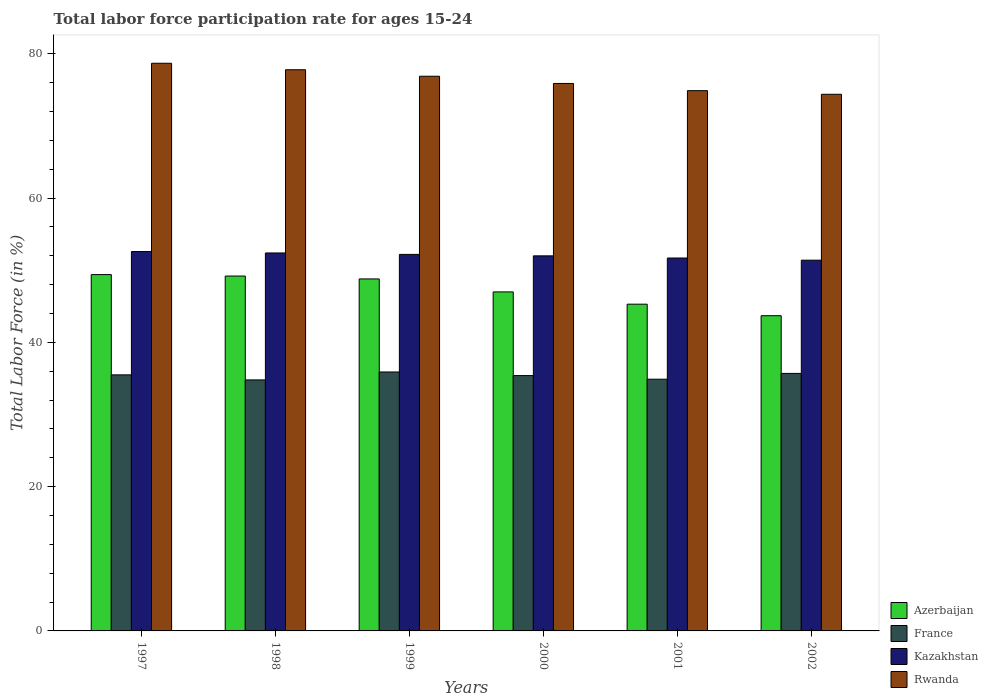How many different coloured bars are there?
Your answer should be very brief. 4. How many groups of bars are there?
Offer a terse response. 6. Are the number of bars per tick equal to the number of legend labels?
Give a very brief answer. Yes. Are the number of bars on each tick of the X-axis equal?
Offer a very short reply. Yes. How many bars are there on the 4th tick from the left?
Give a very brief answer. 4. What is the label of the 6th group of bars from the left?
Your answer should be compact. 2002. What is the labor force participation rate in France in 1998?
Give a very brief answer. 34.8. Across all years, what is the maximum labor force participation rate in Azerbaijan?
Offer a very short reply. 49.4. Across all years, what is the minimum labor force participation rate in Kazakhstan?
Offer a very short reply. 51.4. What is the total labor force participation rate in France in the graph?
Ensure brevity in your answer.  212.2. What is the difference between the labor force participation rate in Azerbaijan in 1999 and that in 2002?
Ensure brevity in your answer.  5.1. What is the difference between the labor force participation rate in France in 2000 and the labor force participation rate in Azerbaijan in 2002?
Your response must be concise. -8.3. What is the average labor force participation rate in Azerbaijan per year?
Provide a succinct answer. 47.23. In the year 2000, what is the difference between the labor force participation rate in Rwanda and labor force participation rate in Kazakhstan?
Your answer should be compact. 23.9. What is the ratio of the labor force participation rate in France in 1998 to that in 2000?
Provide a short and direct response. 0.98. Is the labor force participation rate in Azerbaijan in 2000 less than that in 2002?
Your answer should be very brief. No. Is the difference between the labor force participation rate in Rwanda in 1997 and 2001 greater than the difference between the labor force participation rate in Kazakhstan in 1997 and 2001?
Your response must be concise. Yes. What is the difference between the highest and the second highest labor force participation rate in Rwanda?
Keep it short and to the point. 0.9. What is the difference between the highest and the lowest labor force participation rate in Rwanda?
Your answer should be very brief. 4.3. In how many years, is the labor force participation rate in France greater than the average labor force participation rate in France taken over all years?
Provide a short and direct response. 4. Is the sum of the labor force participation rate in Rwanda in 1997 and 2000 greater than the maximum labor force participation rate in Azerbaijan across all years?
Offer a terse response. Yes. Is it the case that in every year, the sum of the labor force participation rate in Kazakhstan and labor force participation rate in France is greater than the sum of labor force participation rate in Azerbaijan and labor force participation rate in Rwanda?
Keep it short and to the point. No. What does the 3rd bar from the left in 1999 represents?
Give a very brief answer. Kazakhstan. What does the 1st bar from the right in 2000 represents?
Ensure brevity in your answer.  Rwanda. Is it the case that in every year, the sum of the labor force participation rate in France and labor force participation rate in Rwanda is greater than the labor force participation rate in Azerbaijan?
Make the answer very short. Yes. How many bars are there?
Keep it short and to the point. 24. Are all the bars in the graph horizontal?
Your answer should be compact. No. How many years are there in the graph?
Your answer should be compact. 6. Are the values on the major ticks of Y-axis written in scientific E-notation?
Your answer should be very brief. No. Does the graph contain grids?
Your answer should be very brief. No. Where does the legend appear in the graph?
Offer a terse response. Bottom right. How are the legend labels stacked?
Keep it short and to the point. Vertical. What is the title of the graph?
Give a very brief answer. Total labor force participation rate for ages 15-24. Does "Serbia" appear as one of the legend labels in the graph?
Ensure brevity in your answer.  No. What is the label or title of the X-axis?
Your answer should be very brief. Years. What is the Total Labor Force (in %) in Azerbaijan in 1997?
Give a very brief answer. 49.4. What is the Total Labor Force (in %) in France in 1997?
Your answer should be very brief. 35.5. What is the Total Labor Force (in %) in Kazakhstan in 1997?
Provide a short and direct response. 52.6. What is the Total Labor Force (in %) in Rwanda in 1997?
Make the answer very short. 78.7. What is the Total Labor Force (in %) in Azerbaijan in 1998?
Your answer should be compact. 49.2. What is the Total Labor Force (in %) of France in 1998?
Offer a terse response. 34.8. What is the Total Labor Force (in %) of Kazakhstan in 1998?
Give a very brief answer. 52.4. What is the Total Labor Force (in %) of Rwanda in 1998?
Offer a terse response. 77.8. What is the Total Labor Force (in %) in Azerbaijan in 1999?
Offer a terse response. 48.8. What is the Total Labor Force (in %) in France in 1999?
Ensure brevity in your answer.  35.9. What is the Total Labor Force (in %) of Kazakhstan in 1999?
Provide a succinct answer. 52.2. What is the Total Labor Force (in %) of Rwanda in 1999?
Ensure brevity in your answer.  76.9. What is the Total Labor Force (in %) in France in 2000?
Provide a succinct answer. 35.4. What is the Total Labor Force (in %) of Kazakhstan in 2000?
Offer a terse response. 52. What is the Total Labor Force (in %) of Rwanda in 2000?
Provide a short and direct response. 75.9. What is the Total Labor Force (in %) of Azerbaijan in 2001?
Ensure brevity in your answer.  45.3. What is the Total Labor Force (in %) in France in 2001?
Your response must be concise. 34.9. What is the Total Labor Force (in %) in Kazakhstan in 2001?
Give a very brief answer. 51.7. What is the Total Labor Force (in %) of Rwanda in 2001?
Ensure brevity in your answer.  74.9. What is the Total Labor Force (in %) of Azerbaijan in 2002?
Make the answer very short. 43.7. What is the Total Labor Force (in %) in France in 2002?
Make the answer very short. 35.7. What is the Total Labor Force (in %) of Kazakhstan in 2002?
Provide a succinct answer. 51.4. What is the Total Labor Force (in %) in Rwanda in 2002?
Your response must be concise. 74.4. Across all years, what is the maximum Total Labor Force (in %) in Azerbaijan?
Your answer should be compact. 49.4. Across all years, what is the maximum Total Labor Force (in %) of France?
Your answer should be compact. 35.9. Across all years, what is the maximum Total Labor Force (in %) in Kazakhstan?
Provide a succinct answer. 52.6. Across all years, what is the maximum Total Labor Force (in %) of Rwanda?
Offer a terse response. 78.7. Across all years, what is the minimum Total Labor Force (in %) in Azerbaijan?
Your answer should be very brief. 43.7. Across all years, what is the minimum Total Labor Force (in %) of France?
Provide a short and direct response. 34.8. Across all years, what is the minimum Total Labor Force (in %) in Kazakhstan?
Provide a short and direct response. 51.4. Across all years, what is the minimum Total Labor Force (in %) of Rwanda?
Your answer should be very brief. 74.4. What is the total Total Labor Force (in %) of Azerbaijan in the graph?
Offer a terse response. 283.4. What is the total Total Labor Force (in %) in France in the graph?
Your answer should be compact. 212.2. What is the total Total Labor Force (in %) of Kazakhstan in the graph?
Make the answer very short. 312.3. What is the total Total Labor Force (in %) in Rwanda in the graph?
Offer a very short reply. 458.6. What is the difference between the Total Labor Force (in %) of Rwanda in 1997 and that in 1998?
Give a very brief answer. 0.9. What is the difference between the Total Labor Force (in %) of Azerbaijan in 1997 and that in 1999?
Ensure brevity in your answer.  0.6. What is the difference between the Total Labor Force (in %) of Rwanda in 1997 and that in 1999?
Your answer should be very brief. 1.8. What is the difference between the Total Labor Force (in %) in France in 1997 and that in 2000?
Offer a very short reply. 0.1. What is the difference between the Total Labor Force (in %) in Rwanda in 1997 and that in 2000?
Your answer should be compact. 2.8. What is the difference between the Total Labor Force (in %) of France in 1997 and that in 2001?
Give a very brief answer. 0.6. What is the difference between the Total Labor Force (in %) in Kazakhstan in 1997 and that in 2001?
Provide a succinct answer. 0.9. What is the difference between the Total Labor Force (in %) in Rwanda in 1997 and that in 2001?
Your answer should be compact. 3.8. What is the difference between the Total Labor Force (in %) of France in 1997 and that in 2002?
Provide a succinct answer. -0.2. What is the difference between the Total Labor Force (in %) of Rwanda in 1997 and that in 2002?
Keep it short and to the point. 4.3. What is the difference between the Total Labor Force (in %) of France in 1998 and that in 1999?
Give a very brief answer. -1.1. What is the difference between the Total Labor Force (in %) in Rwanda in 1998 and that in 1999?
Ensure brevity in your answer.  0.9. What is the difference between the Total Labor Force (in %) of Azerbaijan in 1998 and that in 2000?
Make the answer very short. 2.2. What is the difference between the Total Labor Force (in %) in France in 1998 and that in 2000?
Provide a short and direct response. -0.6. What is the difference between the Total Labor Force (in %) in Kazakhstan in 1998 and that in 2000?
Give a very brief answer. 0.4. What is the difference between the Total Labor Force (in %) in Azerbaijan in 1998 and that in 2001?
Keep it short and to the point. 3.9. What is the difference between the Total Labor Force (in %) of France in 1998 and that in 2001?
Provide a succinct answer. -0.1. What is the difference between the Total Labor Force (in %) in France in 1998 and that in 2002?
Keep it short and to the point. -0.9. What is the difference between the Total Labor Force (in %) in Kazakhstan in 1998 and that in 2002?
Keep it short and to the point. 1. What is the difference between the Total Labor Force (in %) of Rwanda in 1998 and that in 2002?
Your response must be concise. 3.4. What is the difference between the Total Labor Force (in %) in France in 1999 and that in 2000?
Offer a very short reply. 0.5. What is the difference between the Total Labor Force (in %) of Azerbaijan in 1999 and that in 2002?
Provide a short and direct response. 5.1. What is the difference between the Total Labor Force (in %) of Rwanda in 1999 and that in 2002?
Make the answer very short. 2.5. What is the difference between the Total Labor Force (in %) of Azerbaijan in 2000 and that in 2001?
Your answer should be very brief. 1.7. What is the difference between the Total Labor Force (in %) in France in 2000 and that in 2002?
Provide a succinct answer. -0.3. What is the difference between the Total Labor Force (in %) of Rwanda in 2000 and that in 2002?
Offer a terse response. 1.5. What is the difference between the Total Labor Force (in %) in Rwanda in 2001 and that in 2002?
Offer a very short reply. 0.5. What is the difference between the Total Labor Force (in %) in Azerbaijan in 1997 and the Total Labor Force (in %) in Kazakhstan in 1998?
Make the answer very short. -3. What is the difference between the Total Labor Force (in %) in Azerbaijan in 1997 and the Total Labor Force (in %) in Rwanda in 1998?
Ensure brevity in your answer.  -28.4. What is the difference between the Total Labor Force (in %) in France in 1997 and the Total Labor Force (in %) in Kazakhstan in 1998?
Keep it short and to the point. -16.9. What is the difference between the Total Labor Force (in %) of France in 1997 and the Total Labor Force (in %) of Rwanda in 1998?
Ensure brevity in your answer.  -42.3. What is the difference between the Total Labor Force (in %) in Kazakhstan in 1997 and the Total Labor Force (in %) in Rwanda in 1998?
Keep it short and to the point. -25.2. What is the difference between the Total Labor Force (in %) of Azerbaijan in 1997 and the Total Labor Force (in %) of Kazakhstan in 1999?
Give a very brief answer. -2.8. What is the difference between the Total Labor Force (in %) of Azerbaijan in 1997 and the Total Labor Force (in %) of Rwanda in 1999?
Your answer should be compact. -27.5. What is the difference between the Total Labor Force (in %) in France in 1997 and the Total Labor Force (in %) in Kazakhstan in 1999?
Offer a terse response. -16.7. What is the difference between the Total Labor Force (in %) in France in 1997 and the Total Labor Force (in %) in Rwanda in 1999?
Ensure brevity in your answer.  -41.4. What is the difference between the Total Labor Force (in %) of Kazakhstan in 1997 and the Total Labor Force (in %) of Rwanda in 1999?
Your answer should be compact. -24.3. What is the difference between the Total Labor Force (in %) in Azerbaijan in 1997 and the Total Labor Force (in %) in Rwanda in 2000?
Make the answer very short. -26.5. What is the difference between the Total Labor Force (in %) of France in 1997 and the Total Labor Force (in %) of Kazakhstan in 2000?
Give a very brief answer. -16.5. What is the difference between the Total Labor Force (in %) of France in 1997 and the Total Labor Force (in %) of Rwanda in 2000?
Give a very brief answer. -40.4. What is the difference between the Total Labor Force (in %) in Kazakhstan in 1997 and the Total Labor Force (in %) in Rwanda in 2000?
Your answer should be very brief. -23.3. What is the difference between the Total Labor Force (in %) in Azerbaijan in 1997 and the Total Labor Force (in %) in Rwanda in 2001?
Your answer should be compact. -25.5. What is the difference between the Total Labor Force (in %) in France in 1997 and the Total Labor Force (in %) in Kazakhstan in 2001?
Your response must be concise. -16.2. What is the difference between the Total Labor Force (in %) of France in 1997 and the Total Labor Force (in %) of Rwanda in 2001?
Your answer should be compact. -39.4. What is the difference between the Total Labor Force (in %) of Kazakhstan in 1997 and the Total Labor Force (in %) of Rwanda in 2001?
Your response must be concise. -22.3. What is the difference between the Total Labor Force (in %) in Azerbaijan in 1997 and the Total Labor Force (in %) in Rwanda in 2002?
Offer a terse response. -25. What is the difference between the Total Labor Force (in %) of France in 1997 and the Total Labor Force (in %) of Kazakhstan in 2002?
Your answer should be very brief. -15.9. What is the difference between the Total Labor Force (in %) of France in 1997 and the Total Labor Force (in %) of Rwanda in 2002?
Your answer should be very brief. -38.9. What is the difference between the Total Labor Force (in %) of Kazakhstan in 1997 and the Total Labor Force (in %) of Rwanda in 2002?
Ensure brevity in your answer.  -21.8. What is the difference between the Total Labor Force (in %) in Azerbaijan in 1998 and the Total Labor Force (in %) in Kazakhstan in 1999?
Offer a very short reply. -3. What is the difference between the Total Labor Force (in %) in Azerbaijan in 1998 and the Total Labor Force (in %) in Rwanda in 1999?
Provide a short and direct response. -27.7. What is the difference between the Total Labor Force (in %) in France in 1998 and the Total Labor Force (in %) in Kazakhstan in 1999?
Give a very brief answer. -17.4. What is the difference between the Total Labor Force (in %) of France in 1998 and the Total Labor Force (in %) of Rwanda in 1999?
Your answer should be compact. -42.1. What is the difference between the Total Labor Force (in %) of Kazakhstan in 1998 and the Total Labor Force (in %) of Rwanda in 1999?
Ensure brevity in your answer.  -24.5. What is the difference between the Total Labor Force (in %) in Azerbaijan in 1998 and the Total Labor Force (in %) in Kazakhstan in 2000?
Your answer should be compact. -2.8. What is the difference between the Total Labor Force (in %) of Azerbaijan in 1998 and the Total Labor Force (in %) of Rwanda in 2000?
Provide a succinct answer. -26.7. What is the difference between the Total Labor Force (in %) in France in 1998 and the Total Labor Force (in %) in Kazakhstan in 2000?
Your answer should be compact. -17.2. What is the difference between the Total Labor Force (in %) of France in 1998 and the Total Labor Force (in %) of Rwanda in 2000?
Keep it short and to the point. -41.1. What is the difference between the Total Labor Force (in %) of Kazakhstan in 1998 and the Total Labor Force (in %) of Rwanda in 2000?
Make the answer very short. -23.5. What is the difference between the Total Labor Force (in %) in Azerbaijan in 1998 and the Total Labor Force (in %) in France in 2001?
Provide a short and direct response. 14.3. What is the difference between the Total Labor Force (in %) in Azerbaijan in 1998 and the Total Labor Force (in %) in Kazakhstan in 2001?
Offer a terse response. -2.5. What is the difference between the Total Labor Force (in %) in Azerbaijan in 1998 and the Total Labor Force (in %) in Rwanda in 2001?
Offer a terse response. -25.7. What is the difference between the Total Labor Force (in %) of France in 1998 and the Total Labor Force (in %) of Kazakhstan in 2001?
Offer a terse response. -16.9. What is the difference between the Total Labor Force (in %) in France in 1998 and the Total Labor Force (in %) in Rwanda in 2001?
Provide a short and direct response. -40.1. What is the difference between the Total Labor Force (in %) in Kazakhstan in 1998 and the Total Labor Force (in %) in Rwanda in 2001?
Provide a succinct answer. -22.5. What is the difference between the Total Labor Force (in %) of Azerbaijan in 1998 and the Total Labor Force (in %) of Kazakhstan in 2002?
Provide a short and direct response. -2.2. What is the difference between the Total Labor Force (in %) in Azerbaijan in 1998 and the Total Labor Force (in %) in Rwanda in 2002?
Keep it short and to the point. -25.2. What is the difference between the Total Labor Force (in %) in France in 1998 and the Total Labor Force (in %) in Kazakhstan in 2002?
Keep it short and to the point. -16.6. What is the difference between the Total Labor Force (in %) of France in 1998 and the Total Labor Force (in %) of Rwanda in 2002?
Offer a terse response. -39.6. What is the difference between the Total Labor Force (in %) of Azerbaijan in 1999 and the Total Labor Force (in %) of France in 2000?
Offer a terse response. 13.4. What is the difference between the Total Labor Force (in %) in Azerbaijan in 1999 and the Total Labor Force (in %) in Kazakhstan in 2000?
Make the answer very short. -3.2. What is the difference between the Total Labor Force (in %) in Azerbaijan in 1999 and the Total Labor Force (in %) in Rwanda in 2000?
Give a very brief answer. -27.1. What is the difference between the Total Labor Force (in %) in France in 1999 and the Total Labor Force (in %) in Kazakhstan in 2000?
Give a very brief answer. -16.1. What is the difference between the Total Labor Force (in %) in France in 1999 and the Total Labor Force (in %) in Rwanda in 2000?
Give a very brief answer. -40. What is the difference between the Total Labor Force (in %) of Kazakhstan in 1999 and the Total Labor Force (in %) of Rwanda in 2000?
Provide a short and direct response. -23.7. What is the difference between the Total Labor Force (in %) in Azerbaijan in 1999 and the Total Labor Force (in %) in Kazakhstan in 2001?
Your answer should be compact. -2.9. What is the difference between the Total Labor Force (in %) in Azerbaijan in 1999 and the Total Labor Force (in %) in Rwanda in 2001?
Your answer should be compact. -26.1. What is the difference between the Total Labor Force (in %) in France in 1999 and the Total Labor Force (in %) in Kazakhstan in 2001?
Offer a very short reply. -15.8. What is the difference between the Total Labor Force (in %) of France in 1999 and the Total Labor Force (in %) of Rwanda in 2001?
Offer a very short reply. -39. What is the difference between the Total Labor Force (in %) of Kazakhstan in 1999 and the Total Labor Force (in %) of Rwanda in 2001?
Offer a terse response. -22.7. What is the difference between the Total Labor Force (in %) in Azerbaijan in 1999 and the Total Labor Force (in %) in France in 2002?
Make the answer very short. 13.1. What is the difference between the Total Labor Force (in %) of Azerbaijan in 1999 and the Total Labor Force (in %) of Rwanda in 2002?
Provide a succinct answer. -25.6. What is the difference between the Total Labor Force (in %) in France in 1999 and the Total Labor Force (in %) in Kazakhstan in 2002?
Offer a terse response. -15.5. What is the difference between the Total Labor Force (in %) in France in 1999 and the Total Labor Force (in %) in Rwanda in 2002?
Provide a short and direct response. -38.5. What is the difference between the Total Labor Force (in %) of Kazakhstan in 1999 and the Total Labor Force (in %) of Rwanda in 2002?
Your answer should be compact. -22.2. What is the difference between the Total Labor Force (in %) of Azerbaijan in 2000 and the Total Labor Force (in %) of France in 2001?
Your response must be concise. 12.1. What is the difference between the Total Labor Force (in %) in Azerbaijan in 2000 and the Total Labor Force (in %) in Kazakhstan in 2001?
Keep it short and to the point. -4.7. What is the difference between the Total Labor Force (in %) in Azerbaijan in 2000 and the Total Labor Force (in %) in Rwanda in 2001?
Provide a succinct answer. -27.9. What is the difference between the Total Labor Force (in %) of France in 2000 and the Total Labor Force (in %) of Kazakhstan in 2001?
Offer a very short reply. -16.3. What is the difference between the Total Labor Force (in %) of France in 2000 and the Total Labor Force (in %) of Rwanda in 2001?
Provide a succinct answer. -39.5. What is the difference between the Total Labor Force (in %) in Kazakhstan in 2000 and the Total Labor Force (in %) in Rwanda in 2001?
Offer a very short reply. -22.9. What is the difference between the Total Labor Force (in %) of Azerbaijan in 2000 and the Total Labor Force (in %) of France in 2002?
Make the answer very short. 11.3. What is the difference between the Total Labor Force (in %) in Azerbaijan in 2000 and the Total Labor Force (in %) in Kazakhstan in 2002?
Provide a succinct answer. -4.4. What is the difference between the Total Labor Force (in %) of Azerbaijan in 2000 and the Total Labor Force (in %) of Rwanda in 2002?
Your answer should be compact. -27.4. What is the difference between the Total Labor Force (in %) of France in 2000 and the Total Labor Force (in %) of Rwanda in 2002?
Keep it short and to the point. -39. What is the difference between the Total Labor Force (in %) of Kazakhstan in 2000 and the Total Labor Force (in %) of Rwanda in 2002?
Provide a succinct answer. -22.4. What is the difference between the Total Labor Force (in %) of Azerbaijan in 2001 and the Total Labor Force (in %) of France in 2002?
Provide a succinct answer. 9.6. What is the difference between the Total Labor Force (in %) in Azerbaijan in 2001 and the Total Labor Force (in %) in Rwanda in 2002?
Your response must be concise. -29.1. What is the difference between the Total Labor Force (in %) in France in 2001 and the Total Labor Force (in %) in Kazakhstan in 2002?
Provide a short and direct response. -16.5. What is the difference between the Total Labor Force (in %) of France in 2001 and the Total Labor Force (in %) of Rwanda in 2002?
Give a very brief answer. -39.5. What is the difference between the Total Labor Force (in %) in Kazakhstan in 2001 and the Total Labor Force (in %) in Rwanda in 2002?
Provide a short and direct response. -22.7. What is the average Total Labor Force (in %) in Azerbaijan per year?
Ensure brevity in your answer.  47.23. What is the average Total Labor Force (in %) of France per year?
Your answer should be very brief. 35.37. What is the average Total Labor Force (in %) in Kazakhstan per year?
Keep it short and to the point. 52.05. What is the average Total Labor Force (in %) in Rwanda per year?
Give a very brief answer. 76.43. In the year 1997, what is the difference between the Total Labor Force (in %) in Azerbaijan and Total Labor Force (in %) in Rwanda?
Make the answer very short. -29.3. In the year 1997, what is the difference between the Total Labor Force (in %) in France and Total Labor Force (in %) in Kazakhstan?
Ensure brevity in your answer.  -17.1. In the year 1997, what is the difference between the Total Labor Force (in %) in France and Total Labor Force (in %) in Rwanda?
Offer a terse response. -43.2. In the year 1997, what is the difference between the Total Labor Force (in %) of Kazakhstan and Total Labor Force (in %) of Rwanda?
Your answer should be compact. -26.1. In the year 1998, what is the difference between the Total Labor Force (in %) of Azerbaijan and Total Labor Force (in %) of Rwanda?
Provide a succinct answer. -28.6. In the year 1998, what is the difference between the Total Labor Force (in %) in France and Total Labor Force (in %) in Kazakhstan?
Provide a succinct answer. -17.6. In the year 1998, what is the difference between the Total Labor Force (in %) of France and Total Labor Force (in %) of Rwanda?
Provide a short and direct response. -43. In the year 1998, what is the difference between the Total Labor Force (in %) of Kazakhstan and Total Labor Force (in %) of Rwanda?
Offer a very short reply. -25.4. In the year 1999, what is the difference between the Total Labor Force (in %) of Azerbaijan and Total Labor Force (in %) of Rwanda?
Make the answer very short. -28.1. In the year 1999, what is the difference between the Total Labor Force (in %) in France and Total Labor Force (in %) in Kazakhstan?
Provide a succinct answer. -16.3. In the year 1999, what is the difference between the Total Labor Force (in %) of France and Total Labor Force (in %) of Rwanda?
Provide a short and direct response. -41. In the year 1999, what is the difference between the Total Labor Force (in %) of Kazakhstan and Total Labor Force (in %) of Rwanda?
Offer a very short reply. -24.7. In the year 2000, what is the difference between the Total Labor Force (in %) of Azerbaijan and Total Labor Force (in %) of France?
Provide a succinct answer. 11.6. In the year 2000, what is the difference between the Total Labor Force (in %) of Azerbaijan and Total Labor Force (in %) of Rwanda?
Provide a succinct answer. -28.9. In the year 2000, what is the difference between the Total Labor Force (in %) in France and Total Labor Force (in %) in Kazakhstan?
Offer a terse response. -16.6. In the year 2000, what is the difference between the Total Labor Force (in %) of France and Total Labor Force (in %) of Rwanda?
Ensure brevity in your answer.  -40.5. In the year 2000, what is the difference between the Total Labor Force (in %) of Kazakhstan and Total Labor Force (in %) of Rwanda?
Make the answer very short. -23.9. In the year 2001, what is the difference between the Total Labor Force (in %) in Azerbaijan and Total Labor Force (in %) in Rwanda?
Offer a terse response. -29.6. In the year 2001, what is the difference between the Total Labor Force (in %) of France and Total Labor Force (in %) of Kazakhstan?
Offer a terse response. -16.8. In the year 2001, what is the difference between the Total Labor Force (in %) of Kazakhstan and Total Labor Force (in %) of Rwanda?
Offer a terse response. -23.2. In the year 2002, what is the difference between the Total Labor Force (in %) of Azerbaijan and Total Labor Force (in %) of France?
Ensure brevity in your answer.  8. In the year 2002, what is the difference between the Total Labor Force (in %) of Azerbaijan and Total Labor Force (in %) of Rwanda?
Make the answer very short. -30.7. In the year 2002, what is the difference between the Total Labor Force (in %) of France and Total Labor Force (in %) of Kazakhstan?
Ensure brevity in your answer.  -15.7. In the year 2002, what is the difference between the Total Labor Force (in %) of France and Total Labor Force (in %) of Rwanda?
Offer a very short reply. -38.7. What is the ratio of the Total Labor Force (in %) of France in 1997 to that in 1998?
Your response must be concise. 1.02. What is the ratio of the Total Labor Force (in %) in Rwanda in 1997 to that in 1998?
Your answer should be very brief. 1.01. What is the ratio of the Total Labor Force (in %) in Azerbaijan in 1997 to that in 1999?
Your answer should be very brief. 1.01. What is the ratio of the Total Labor Force (in %) of France in 1997 to that in 1999?
Provide a succinct answer. 0.99. What is the ratio of the Total Labor Force (in %) of Kazakhstan in 1997 to that in 1999?
Your response must be concise. 1.01. What is the ratio of the Total Labor Force (in %) of Rwanda in 1997 to that in 1999?
Offer a very short reply. 1.02. What is the ratio of the Total Labor Force (in %) in Azerbaijan in 1997 to that in 2000?
Provide a succinct answer. 1.05. What is the ratio of the Total Labor Force (in %) in France in 1997 to that in 2000?
Provide a succinct answer. 1. What is the ratio of the Total Labor Force (in %) in Kazakhstan in 1997 to that in 2000?
Offer a terse response. 1.01. What is the ratio of the Total Labor Force (in %) in Rwanda in 1997 to that in 2000?
Your answer should be very brief. 1.04. What is the ratio of the Total Labor Force (in %) of Azerbaijan in 1997 to that in 2001?
Your response must be concise. 1.09. What is the ratio of the Total Labor Force (in %) in France in 1997 to that in 2001?
Your answer should be very brief. 1.02. What is the ratio of the Total Labor Force (in %) in Kazakhstan in 1997 to that in 2001?
Offer a very short reply. 1.02. What is the ratio of the Total Labor Force (in %) in Rwanda in 1997 to that in 2001?
Provide a short and direct response. 1.05. What is the ratio of the Total Labor Force (in %) in Azerbaijan in 1997 to that in 2002?
Offer a terse response. 1.13. What is the ratio of the Total Labor Force (in %) in Kazakhstan in 1997 to that in 2002?
Your response must be concise. 1.02. What is the ratio of the Total Labor Force (in %) in Rwanda in 1997 to that in 2002?
Your answer should be very brief. 1.06. What is the ratio of the Total Labor Force (in %) of Azerbaijan in 1998 to that in 1999?
Make the answer very short. 1.01. What is the ratio of the Total Labor Force (in %) in France in 1998 to that in 1999?
Provide a short and direct response. 0.97. What is the ratio of the Total Labor Force (in %) of Kazakhstan in 1998 to that in 1999?
Keep it short and to the point. 1. What is the ratio of the Total Labor Force (in %) in Rwanda in 1998 to that in 1999?
Your answer should be very brief. 1.01. What is the ratio of the Total Labor Force (in %) of Azerbaijan in 1998 to that in 2000?
Your response must be concise. 1.05. What is the ratio of the Total Labor Force (in %) of France in 1998 to that in 2000?
Your answer should be very brief. 0.98. What is the ratio of the Total Labor Force (in %) of Kazakhstan in 1998 to that in 2000?
Make the answer very short. 1.01. What is the ratio of the Total Labor Force (in %) in Rwanda in 1998 to that in 2000?
Ensure brevity in your answer.  1.02. What is the ratio of the Total Labor Force (in %) of Azerbaijan in 1998 to that in 2001?
Your response must be concise. 1.09. What is the ratio of the Total Labor Force (in %) of Kazakhstan in 1998 to that in 2001?
Your response must be concise. 1.01. What is the ratio of the Total Labor Force (in %) of Rwanda in 1998 to that in 2001?
Make the answer very short. 1.04. What is the ratio of the Total Labor Force (in %) of Azerbaijan in 1998 to that in 2002?
Offer a terse response. 1.13. What is the ratio of the Total Labor Force (in %) in France in 1998 to that in 2002?
Make the answer very short. 0.97. What is the ratio of the Total Labor Force (in %) of Kazakhstan in 1998 to that in 2002?
Offer a very short reply. 1.02. What is the ratio of the Total Labor Force (in %) in Rwanda in 1998 to that in 2002?
Give a very brief answer. 1.05. What is the ratio of the Total Labor Force (in %) of Azerbaijan in 1999 to that in 2000?
Give a very brief answer. 1.04. What is the ratio of the Total Labor Force (in %) in France in 1999 to that in 2000?
Your answer should be very brief. 1.01. What is the ratio of the Total Labor Force (in %) of Rwanda in 1999 to that in 2000?
Offer a very short reply. 1.01. What is the ratio of the Total Labor Force (in %) of Azerbaijan in 1999 to that in 2001?
Your answer should be very brief. 1.08. What is the ratio of the Total Labor Force (in %) of France in 1999 to that in 2001?
Your answer should be compact. 1.03. What is the ratio of the Total Labor Force (in %) in Kazakhstan in 1999 to that in 2001?
Give a very brief answer. 1.01. What is the ratio of the Total Labor Force (in %) in Rwanda in 1999 to that in 2001?
Provide a short and direct response. 1.03. What is the ratio of the Total Labor Force (in %) of Azerbaijan in 1999 to that in 2002?
Your answer should be compact. 1.12. What is the ratio of the Total Labor Force (in %) in France in 1999 to that in 2002?
Your answer should be compact. 1.01. What is the ratio of the Total Labor Force (in %) of Kazakhstan in 1999 to that in 2002?
Provide a short and direct response. 1.02. What is the ratio of the Total Labor Force (in %) in Rwanda in 1999 to that in 2002?
Offer a very short reply. 1.03. What is the ratio of the Total Labor Force (in %) in Azerbaijan in 2000 to that in 2001?
Provide a succinct answer. 1.04. What is the ratio of the Total Labor Force (in %) of France in 2000 to that in 2001?
Your answer should be very brief. 1.01. What is the ratio of the Total Labor Force (in %) in Kazakhstan in 2000 to that in 2001?
Your answer should be very brief. 1.01. What is the ratio of the Total Labor Force (in %) of Rwanda in 2000 to that in 2001?
Offer a very short reply. 1.01. What is the ratio of the Total Labor Force (in %) of Azerbaijan in 2000 to that in 2002?
Your answer should be compact. 1.08. What is the ratio of the Total Labor Force (in %) of Kazakhstan in 2000 to that in 2002?
Keep it short and to the point. 1.01. What is the ratio of the Total Labor Force (in %) in Rwanda in 2000 to that in 2002?
Give a very brief answer. 1.02. What is the ratio of the Total Labor Force (in %) in Azerbaijan in 2001 to that in 2002?
Keep it short and to the point. 1.04. What is the ratio of the Total Labor Force (in %) in France in 2001 to that in 2002?
Keep it short and to the point. 0.98. What is the ratio of the Total Labor Force (in %) of Rwanda in 2001 to that in 2002?
Offer a very short reply. 1.01. What is the difference between the highest and the second highest Total Labor Force (in %) of Azerbaijan?
Ensure brevity in your answer.  0.2. What is the difference between the highest and the lowest Total Labor Force (in %) of France?
Ensure brevity in your answer.  1.1. What is the difference between the highest and the lowest Total Labor Force (in %) in Rwanda?
Your answer should be compact. 4.3. 